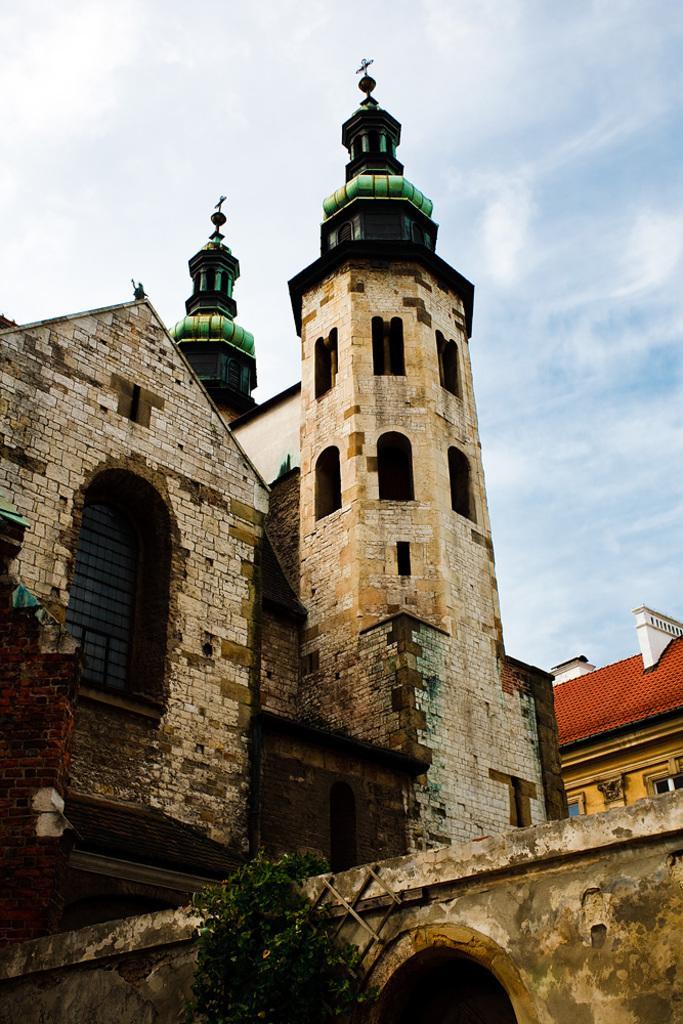Describe this image in one or two sentences. In the center of the image there are buildings. At the top of the image there is sky. 